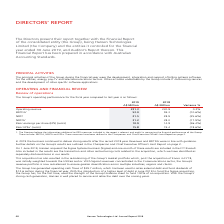According to Hansen Technologies's financial document, How much operating cash flows was generated by Hansen Technologies? According to the financial document, $39.7 million. The relevant text states: "The Group has generated operating cash flows of $39.7 million, which has been used to retire external debt and fund dividends of $12.6 million during the financi..." Also, Which sector was Sigma's revenue concentrated in? According to the financial document, Communications. The relevant text states: "oftware for the utilities, energy, pay-TV and telecommunications sectors. Other activities undertaken by the Group include IT outsourcing services and the developmen..." Also, What was the Operating revenue for 2019? According to the financial document, 231.3 (in millions). The relevant text states: "Operating revenue 231.3 230.8 0.2%..." Also, can you calculate: What was the average difference between EBITDA and NPAT for both FYs? To answer this question, I need to perform calculations using the financial data. The calculation is: ((53.0 - 21.5) + (59.3 - 28.9)) / 2 , which equals 30.95 (in millions). This is based on the information: "NPAT 21.5 28.9 (25.6%) NPAT 21.5 28.9 (25.6%) NPAT 21.5 28.9 (25.6%) EBITDA 1 53.0 59.3 (10.6%) EBITDA 1 53.0 59.3 (10.6%)..." The key data points involved are: 2, 21.5, 28.9. Also, can you calculate: What was the average basic EPSa for both FYs? To answer this question, I need to perform calculations using the financial data. The calculation is: (15.8 + 19.4)/2 , which equals 17.6. This is based on the information: "Basic EPSa 1 (cents) 15.8 19.4 (18.6%) Basic EPSa 1 (cents) 15.8 19.4 (18.6%)..." The key data points involved are: 15.8, 19.4. Also, can you calculate: What was the average difference between basic EPS and basic EPSa for both FYs? To answer this question, I need to perform calculations using the financial data. The calculation is: ((15.8 - 10.9) + (19.4 - 14.8)) / 2 , which equals 4.75. This is based on the information: "Basic EPSa 1 (cents) 15.8 19.4 (18.6%) Basic earnings per share (EPS) (cents) 10.9 14.8 (26.4%) Basic EPSa 1 (cents) 15.8 19.4 (18.6%) Basic earnings per share (EPS) (cents) 10.9 14.8 (26.4%) Basic ea..." The key data points involved are: 10.9, 14.8, 15.8. 